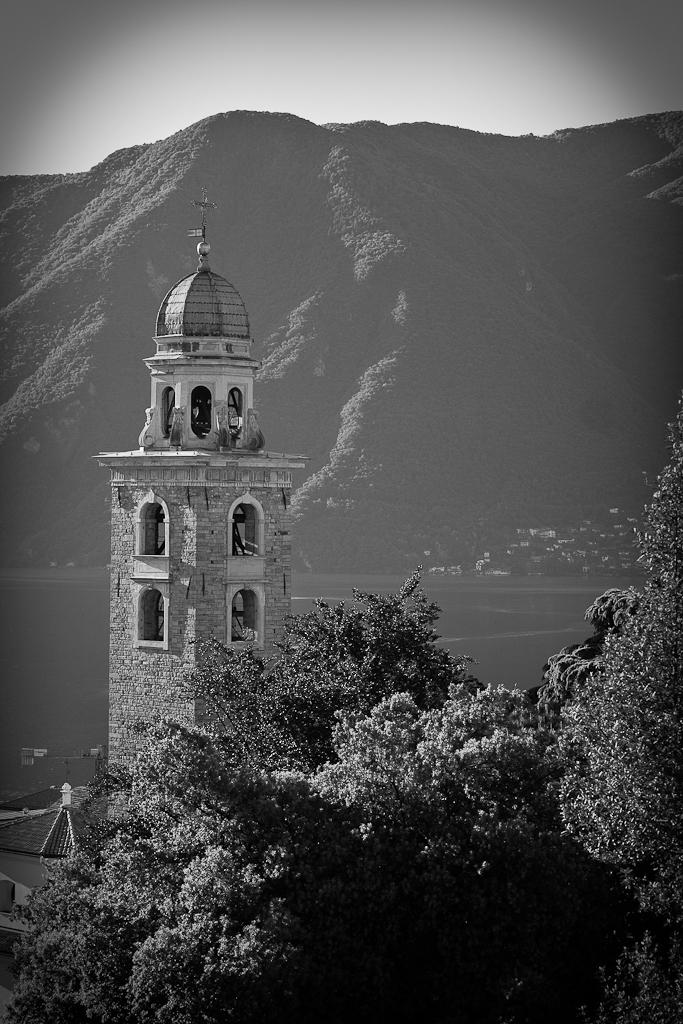What is the color scheme of the image? The image is black and white. What is the main subject in the middle of the image? There is a building in the middle of the image. What type of vegetation can be seen at the bottom of the image? There are trees at the bottom of the image. What geographical features are present in the middle of the image? There are hills in the middle of the image. What is visible at the top of the image? The sky is visible at the top of the image. How many rings are being used by the fairies in the image? There are no rings or fairies present in the image. What type of tail can be seen on the animal in the image? There are no animals or tails visible in the image. 